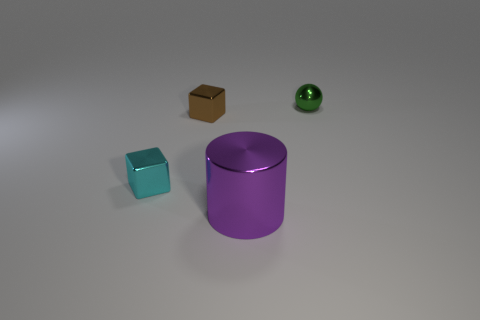There is a tiny cyan metal cube; how many purple metal objects are behind it? 0 